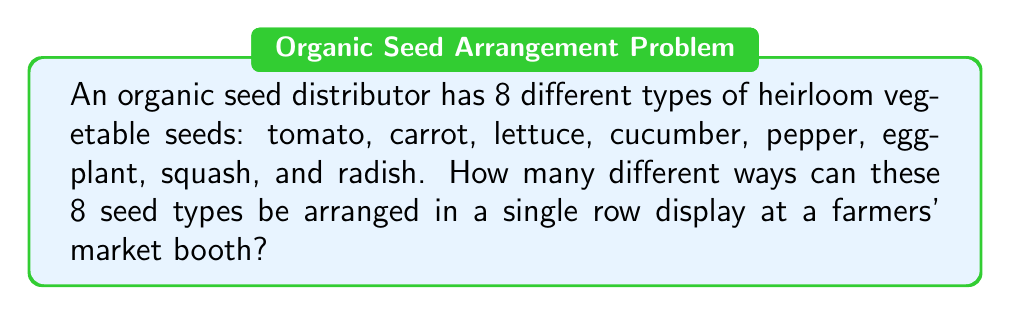Teach me how to tackle this problem. Let's approach this step-by-step:

1) This problem is a classic example of a permutation. We need to arrange all 8 seed types in a specific order, and each seed type can only be used once.

2) In permutation problems, the number of ways to arrange n distinct objects is given by $n!$ (n factorial).

3) In this case, we have 8 distinct seed types, so $n = 8$.

4) Therefore, the number of ways to arrange these seeds is $8!$.

5) Let's calculate $8!$:

   $$8! = 8 \times 7 \times 6 \times 5 \times 4 \times 3 \times 2 \times 1$$

6) Multiplying these numbers:

   $$8! = 40,320$$

Thus, there are 40,320 different ways to arrange these 8 seed types in a single row display.
Answer: $40,320$ 